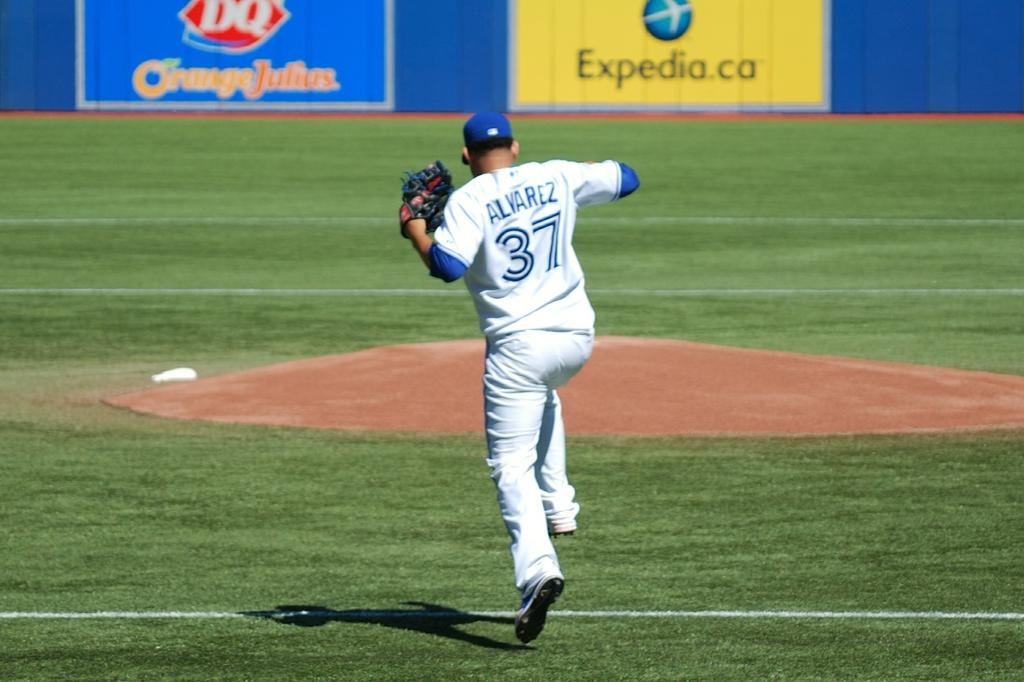<image>
Offer a succinct explanation of the picture presented. a baseball player who is in mid jump and is wearing a number 37 shirt. 